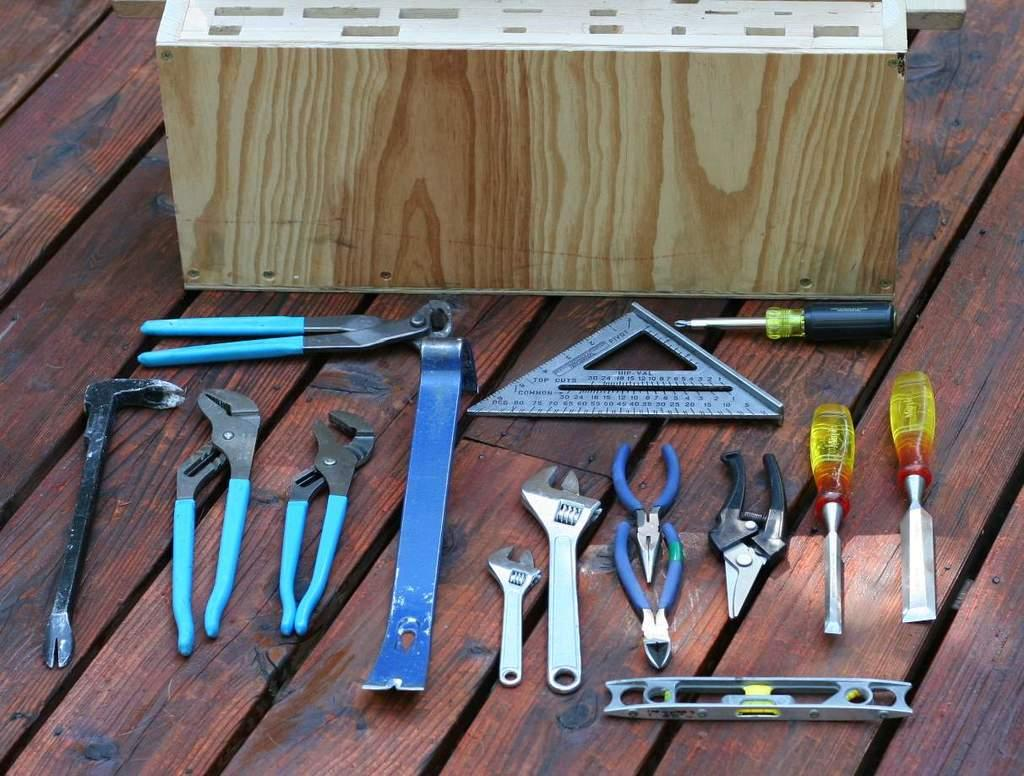What type of items can be seen in the image? There are tools and a wooden object in the image. Can you describe the wooden object in the image? The wooden object is on wooden planks. What might the tools be used for? The tools could be used for various purposes, such as construction or repair work. Who is the owner of the wooden object in the image? There is no information about the owner of the wooden object in the image. Is there a balloon in the image? No, there is no balloon present in the image. 